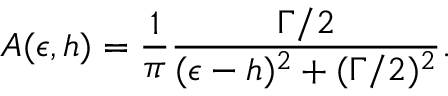<formula> <loc_0><loc_0><loc_500><loc_500>A ( \epsilon , h ) = \frac { 1 } { \pi } \frac { \Gamma / 2 } { ( \epsilon - h ) ^ { 2 } + ( \Gamma / 2 ) ^ { 2 } } .</formula> 